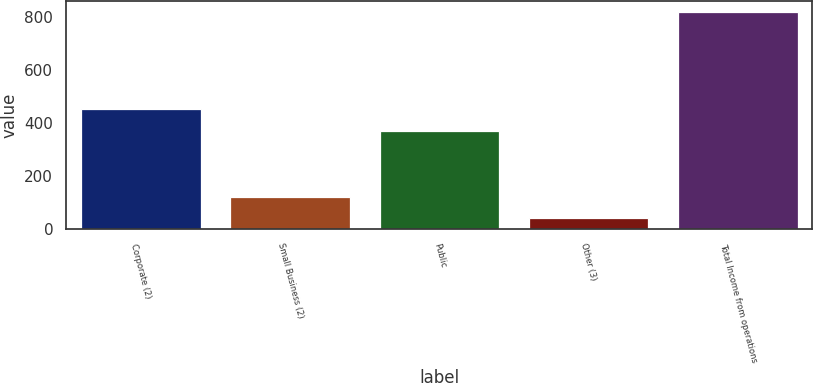<chart> <loc_0><loc_0><loc_500><loc_500><bar_chart><fcel>Corporate (2)<fcel>Small Business (2)<fcel>Public<fcel>Other (3)<fcel>Total Income from operations<nl><fcel>453.6<fcel>121.16<fcel>368<fcel>43.6<fcel>819.2<nl></chart> 